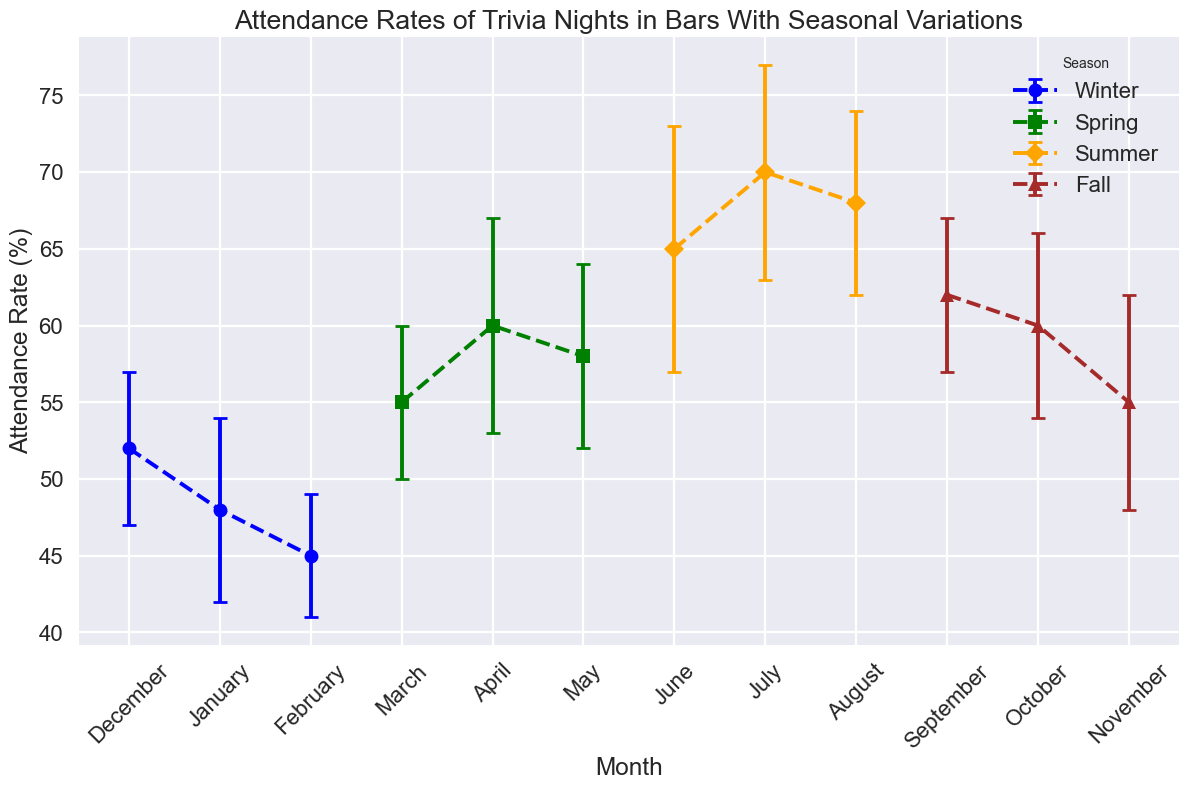Which month has the highest attendance rate? The month with the highest attendance rate is the one where the data point is the highest on the y-axis. In this case, July has the highest attendance rate.
Answer: July Which season has the lowest average attendance rate? To find the lowest average attendance rate, we need to calculate the average attendance for each season and then compare them. For Winter: (52+48+45)/3 = 48.33; for Spring: (55+60+58)/3 = 57.67; for Summer: (65+70+68)/3 = 67.67; for Fall: (62+60+55)/3 = 59. Therefore, Winter has the lowest average attendance rate.
Answer: Winter What's the difference in attendance rates between June and August? To find the difference, we subtract the attendance rate of August from that of June: 68 - 65 = 3.
Answer: 3 In which month is the attendance variation (standard deviation) the highest? The month with the highest standard deviation (indicated by the length of the error bars) should be identified. July has the highest standard deviation, which is 8.
Answer: July Is the attendance rate in October higher than in February? To compare, check the y-values for October and February. October has an attendance rate of 60, while February has 45. Therefore, October's attendance rate is higher.
Answer: Yes What is the combined attendance rate for all winter months? To find the combined attendance rate, sum the attendance rates of December, January, and February: 52 + 48 + 45 = 145.
Answer: 145 By how much does the attendance rate increase from January to March? The increase is found by subtracting January's rate from March's rate: 55 - 48 = 7.
Answer: 7 Which season shows the most consistent attendance rates based on the standard deviations? The most consistent attendance is indicated by the smallest average standard deviation. Calculate the average standard deviation for each season. Winter: (5+6+4)/3 = 5; Spring: (5+7+6)/3 = 6; Summer: (8+7+6)/3 = 7; Fall: (5+6+7)/3 = 6. Therefore, Winter shows the most consistent attendance rates.
Answer: Winter How does the attendance rate in November compare to that in April? To compare, check the y-values for November and April. November has an attendance rate of 55, while April has 60. Therefore, November's attendance rate is lower.
Answer: Lower 